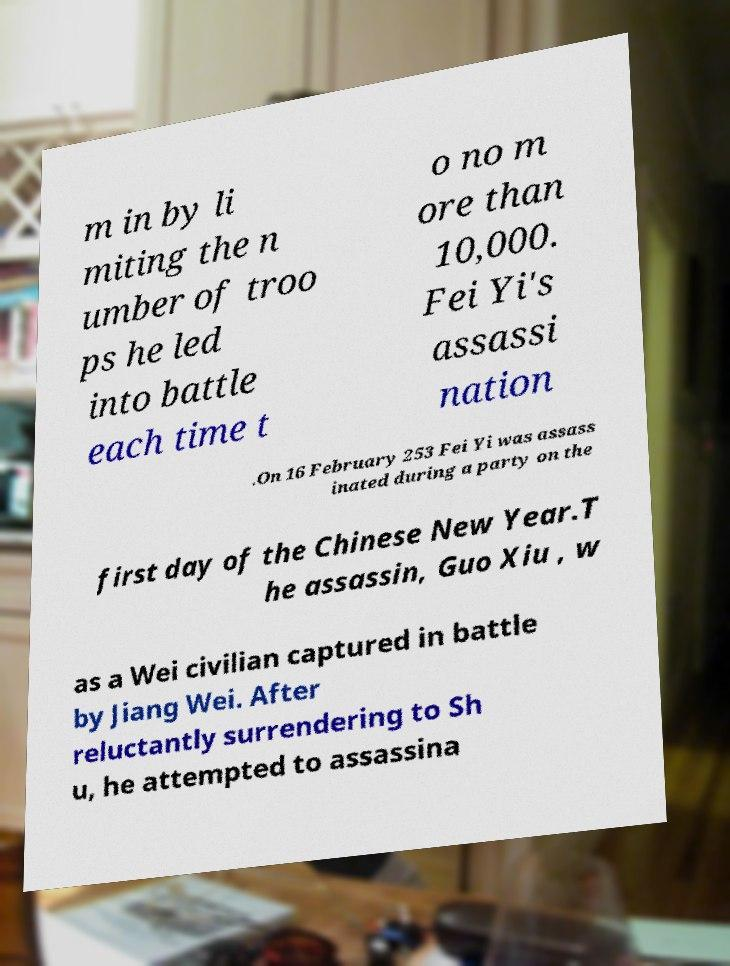For documentation purposes, I need the text within this image transcribed. Could you provide that? m in by li miting the n umber of troo ps he led into battle each time t o no m ore than 10,000. Fei Yi's assassi nation .On 16 February 253 Fei Yi was assass inated during a party on the first day of the Chinese New Year.T he assassin, Guo Xiu , w as a Wei civilian captured in battle by Jiang Wei. After reluctantly surrendering to Sh u, he attempted to assassina 